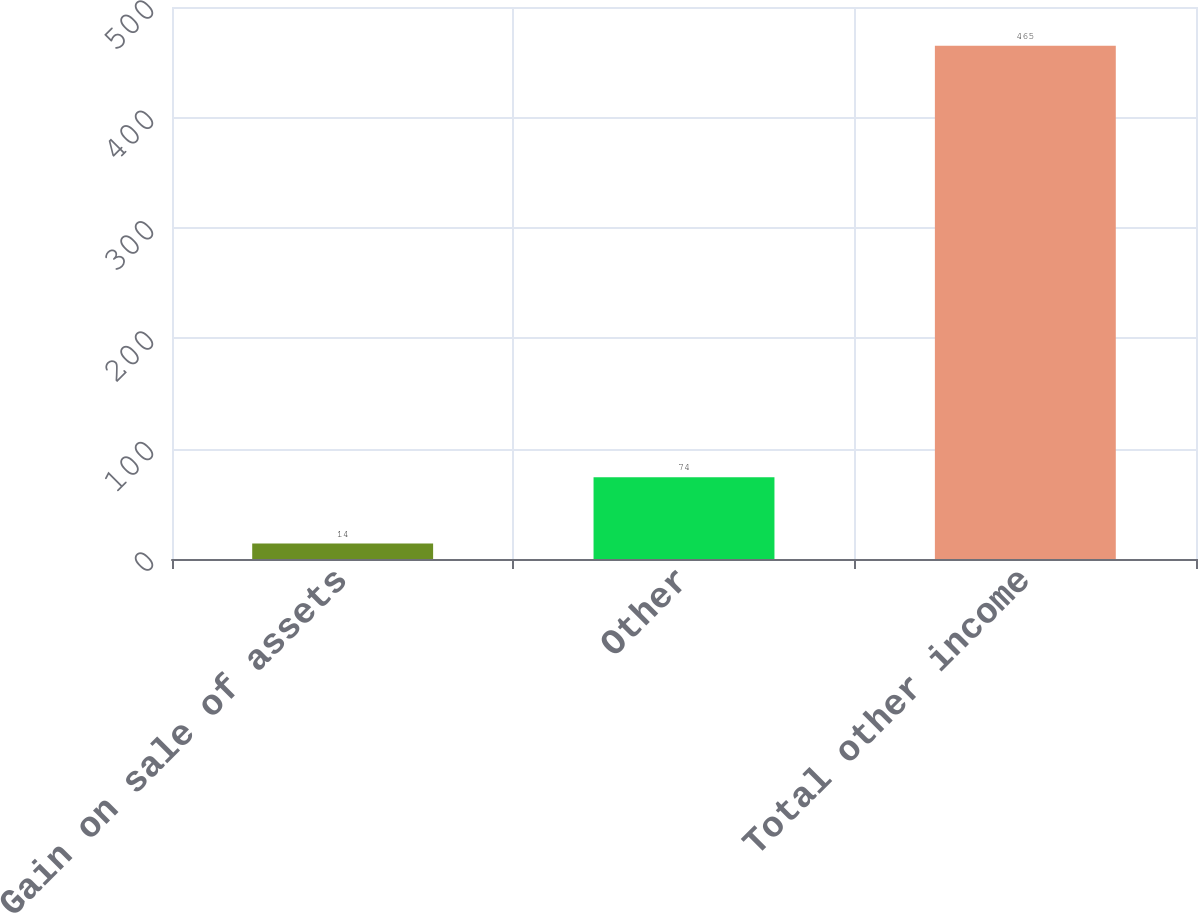<chart> <loc_0><loc_0><loc_500><loc_500><bar_chart><fcel>Gain on sale of assets<fcel>Other<fcel>Total other income<nl><fcel>14<fcel>74<fcel>465<nl></chart> 